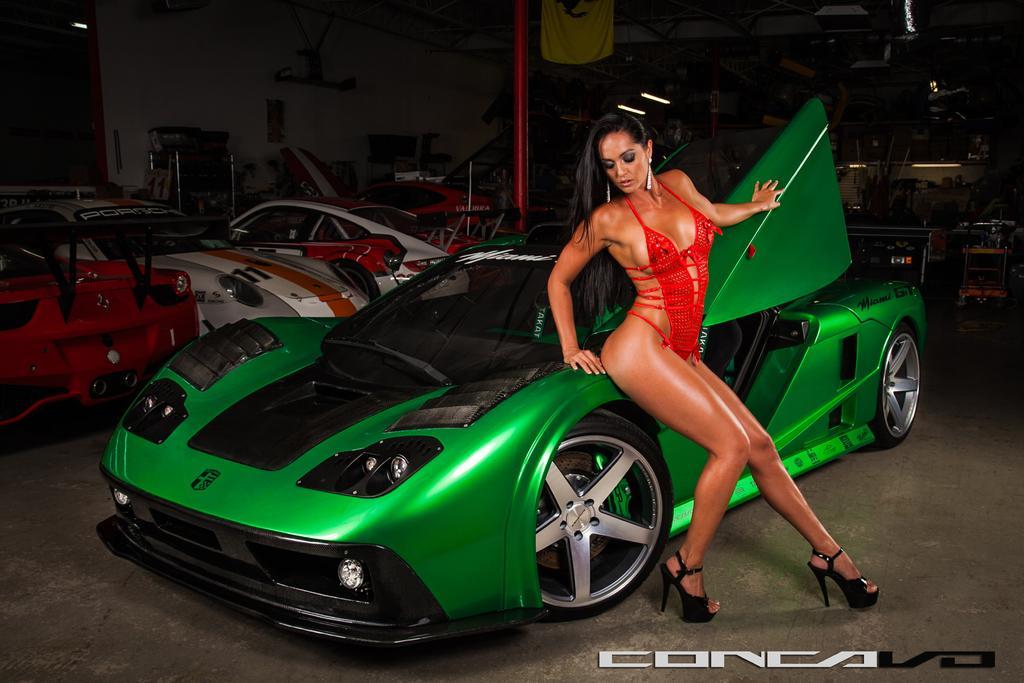How would you summarize this image in a sentence or two? In this image I can see a car which is green and black in color on the ground and I can see a woman wearing red color dress is leaning on the car. In the background I can see few other cars which are red and white in color, the wall which is white in color, two lights and few other objects. 